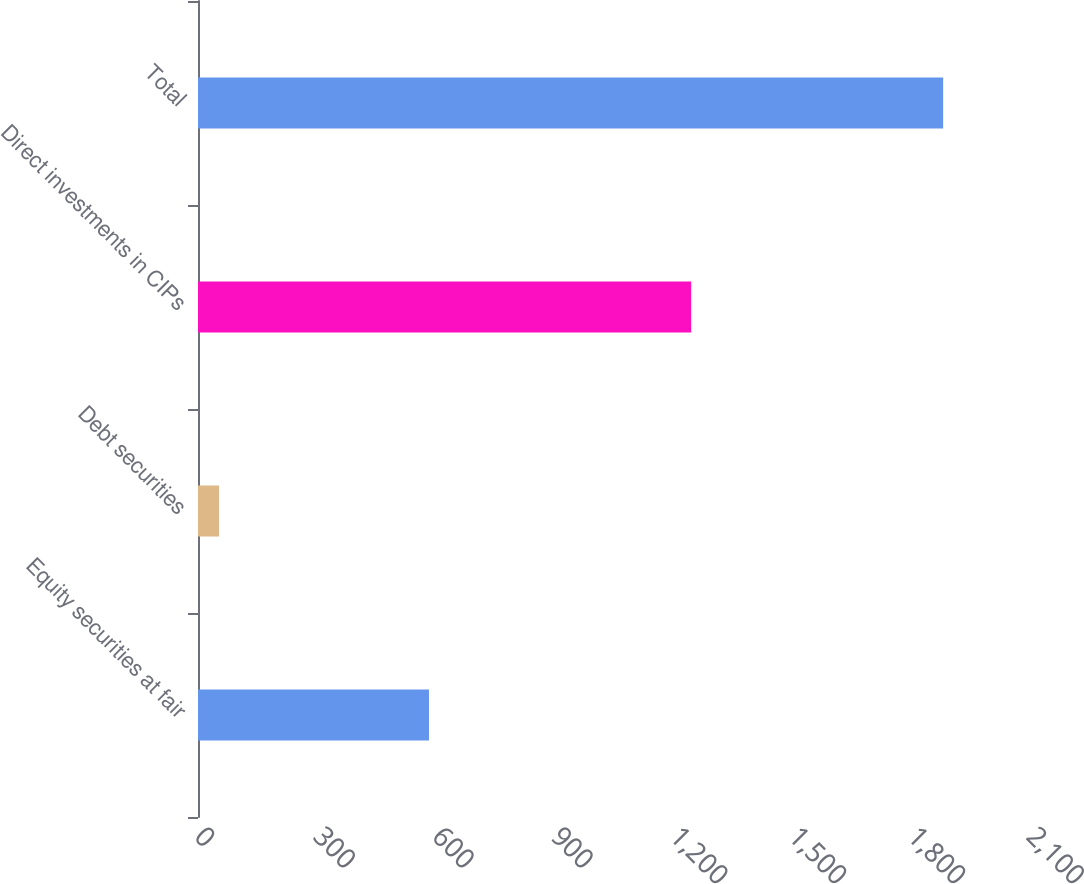Convert chart to OTSL. <chart><loc_0><loc_0><loc_500><loc_500><bar_chart><fcel>Equity securities at fair<fcel>Debt securities<fcel>Direct investments in CIPs<fcel>Total<nl><fcel>583<fcel>53<fcel>1244.8<fcel>1880.8<nl></chart> 